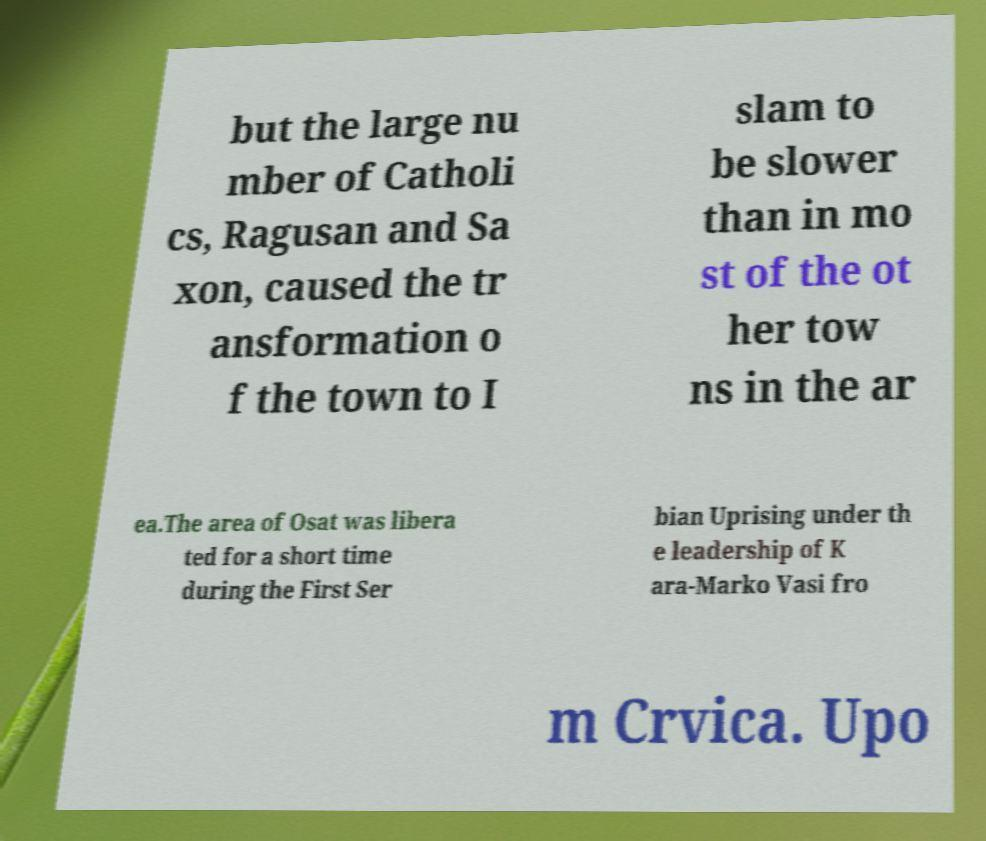There's text embedded in this image that I need extracted. Can you transcribe it verbatim? but the large nu mber of Catholi cs, Ragusan and Sa xon, caused the tr ansformation o f the town to I slam to be slower than in mo st of the ot her tow ns in the ar ea.The area of Osat was libera ted for a short time during the First Ser bian Uprising under th e leadership of K ara-Marko Vasi fro m Crvica. Upo 